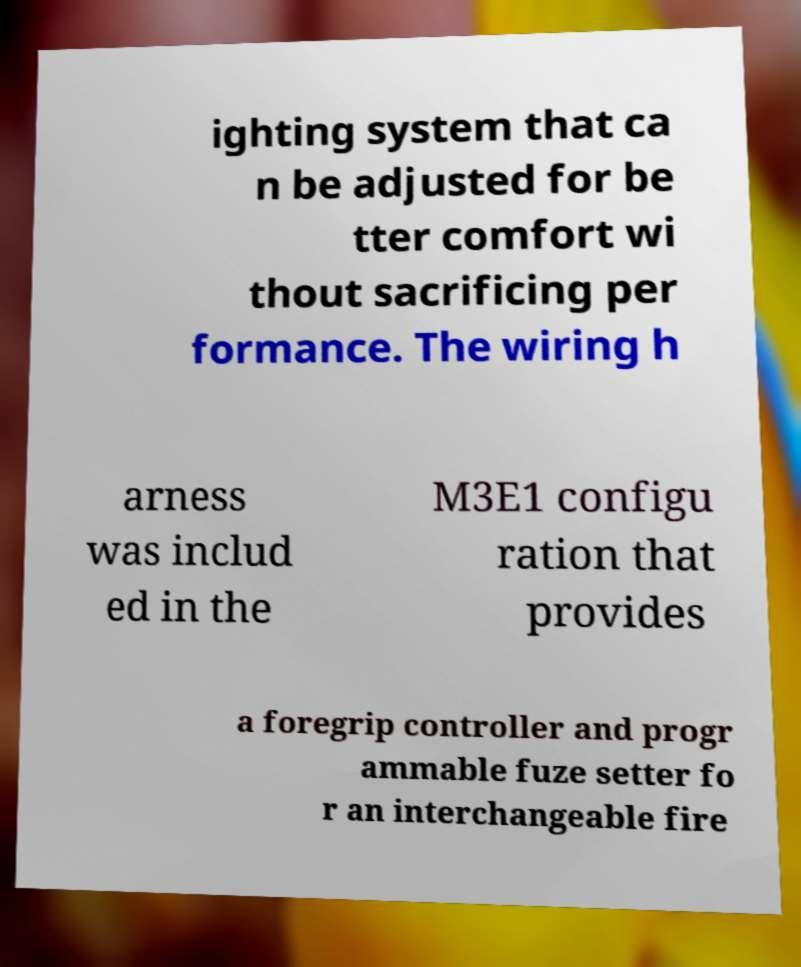Can you accurately transcribe the text from the provided image for me? ighting system that ca n be adjusted for be tter comfort wi thout sacrificing per formance. The wiring h arness was includ ed in the M3E1 configu ration that provides a foregrip controller and progr ammable fuze setter fo r an interchangeable fire 